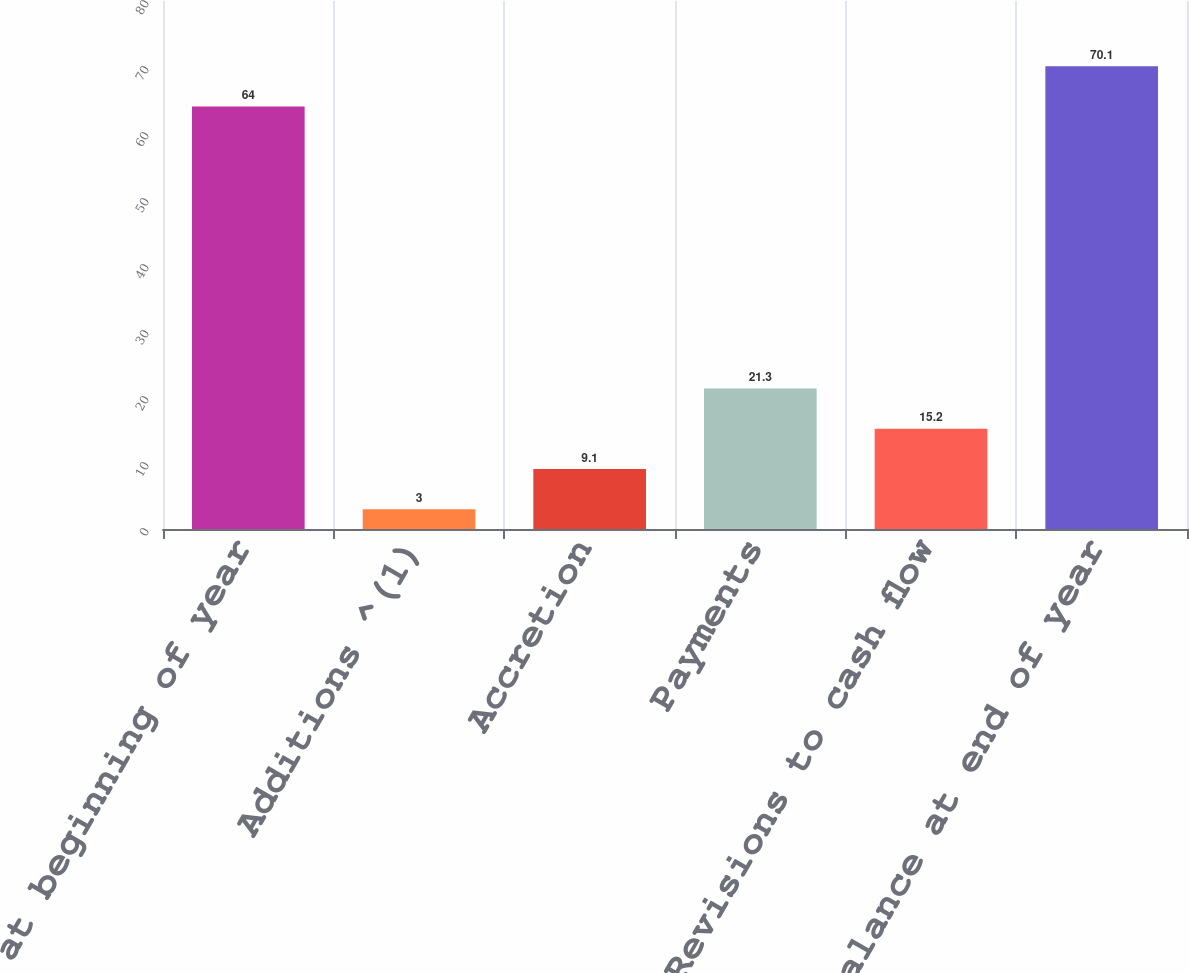<chart> <loc_0><loc_0><loc_500><loc_500><bar_chart><fcel>Balance at beginning of year<fcel>Additions ^(1)<fcel>Accretion<fcel>Payments<fcel>Revisions to cash flow<fcel>Balance at end of year<nl><fcel>64<fcel>3<fcel>9.1<fcel>21.3<fcel>15.2<fcel>70.1<nl></chart> 